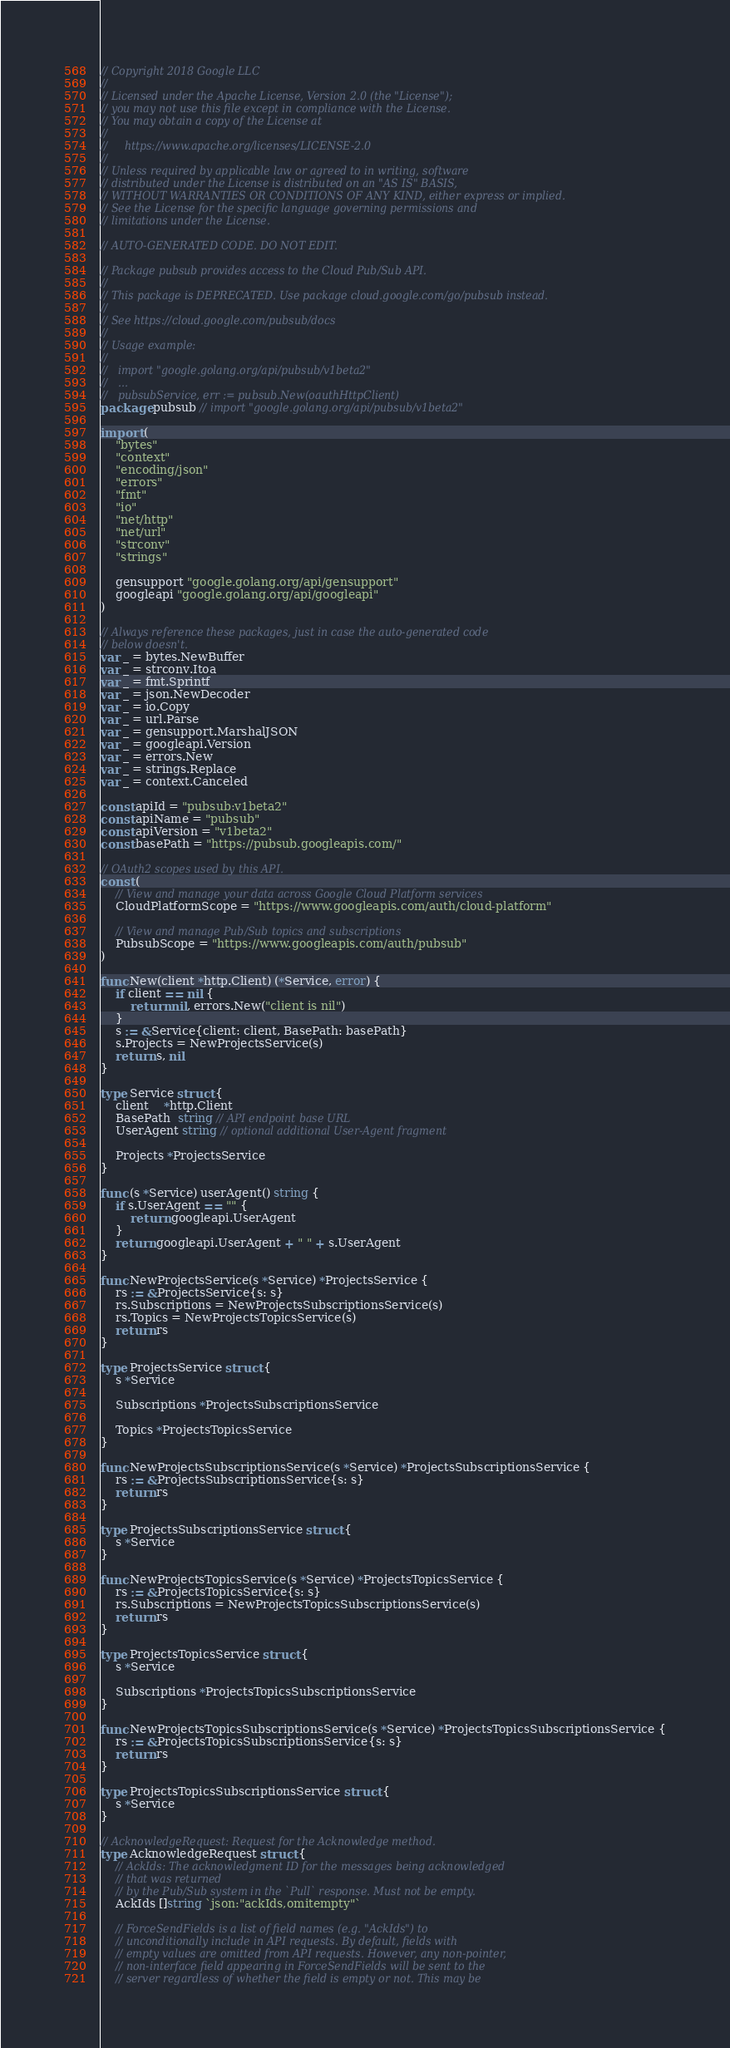Convert code to text. <code><loc_0><loc_0><loc_500><loc_500><_Go_>// Copyright 2018 Google LLC
//
// Licensed under the Apache License, Version 2.0 (the "License");
// you may not use this file except in compliance with the License.
// You may obtain a copy of the License at
//
//     https://www.apache.org/licenses/LICENSE-2.0
//
// Unless required by applicable law or agreed to in writing, software
// distributed under the License is distributed on an "AS IS" BASIS,
// WITHOUT WARRANTIES OR CONDITIONS OF ANY KIND, either express or implied.
// See the License for the specific language governing permissions and
// limitations under the License.

// AUTO-GENERATED CODE. DO NOT EDIT.

// Package pubsub provides access to the Cloud Pub/Sub API.
//
// This package is DEPRECATED. Use package cloud.google.com/go/pubsub instead.
//
// See https://cloud.google.com/pubsub/docs
//
// Usage example:
//
//   import "google.golang.org/api/pubsub/v1beta2"
//   ...
//   pubsubService, err := pubsub.New(oauthHttpClient)
package pubsub // import "google.golang.org/api/pubsub/v1beta2"

import (
	"bytes"
	"context"
	"encoding/json"
	"errors"
	"fmt"
	"io"
	"net/http"
	"net/url"
	"strconv"
	"strings"

	gensupport "google.golang.org/api/gensupport"
	googleapi "google.golang.org/api/googleapi"
)

// Always reference these packages, just in case the auto-generated code
// below doesn't.
var _ = bytes.NewBuffer
var _ = strconv.Itoa
var _ = fmt.Sprintf
var _ = json.NewDecoder
var _ = io.Copy
var _ = url.Parse
var _ = gensupport.MarshalJSON
var _ = googleapi.Version
var _ = errors.New
var _ = strings.Replace
var _ = context.Canceled

const apiId = "pubsub:v1beta2"
const apiName = "pubsub"
const apiVersion = "v1beta2"
const basePath = "https://pubsub.googleapis.com/"

// OAuth2 scopes used by this API.
const (
	// View and manage your data across Google Cloud Platform services
	CloudPlatformScope = "https://www.googleapis.com/auth/cloud-platform"

	// View and manage Pub/Sub topics and subscriptions
	PubsubScope = "https://www.googleapis.com/auth/pubsub"
)

func New(client *http.Client) (*Service, error) {
	if client == nil {
		return nil, errors.New("client is nil")
	}
	s := &Service{client: client, BasePath: basePath}
	s.Projects = NewProjectsService(s)
	return s, nil
}

type Service struct {
	client    *http.Client
	BasePath  string // API endpoint base URL
	UserAgent string // optional additional User-Agent fragment

	Projects *ProjectsService
}

func (s *Service) userAgent() string {
	if s.UserAgent == "" {
		return googleapi.UserAgent
	}
	return googleapi.UserAgent + " " + s.UserAgent
}

func NewProjectsService(s *Service) *ProjectsService {
	rs := &ProjectsService{s: s}
	rs.Subscriptions = NewProjectsSubscriptionsService(s)
	rs.Topics = NewProjectsTopicsService(s)
	return rs
}

type ProjectsService struct {
	s *Service

	Subscriptions *ProjectsSubscriptionsService

	Topics *ProjectsTopicsService
}

func NewProjectsSubscriptionsService(s *Service) *ProjectsSubscriptionsService {
	rs := &ProjectsSubscriptionsService{s: s}
	return rs
}

type ProjectsSubscriptionsService struct {
	s *Service
}

func NewProjectsTopicsService(s *Service) *ProjectsTopicsService {
	rs := &ProjectsTopicsService{s: s}
	rs.Subscriptions = NewProjectsTopicsSubscriptionsService(s)
	return rs
}

type ProjectsTopicsService struct {
	s *Service

	Subscriptions *ProjectsTopicsSubscriptionsService
}

func NewProjectsTopicsSubscriptionsService(s *Service) *ProjectsTopicsSubscriptionsService {
	rs := &ProjectsTopicsSubscriptionsService{s: s}
	return rs
}

type ProjectsTopicsSubscriptionsService struct {
	s *Service
}

// AcknowledgeRequest: Request for the Acknowledge method.
type AcknowledgeRequest struct {
	// AckIds: The acknowledgment ID for the messages being acknowledged
	// that was returned
	// by the Pub/Sub system in the `Pull` response. Must not be empty.
	AckIds []string `json:"ackIds,omitempty"`

	// ForceSendFields is a list of field names (e.g. "AckIds") to
	// unconditionally include in API requests. By default, fields with
	// empty values are omitted from API requests. However, any non-pointer,
	// non-interface field appearing in ForceSendFields will be sent to the
	// server regardless of whether the field is empty or not. This may be</code> 